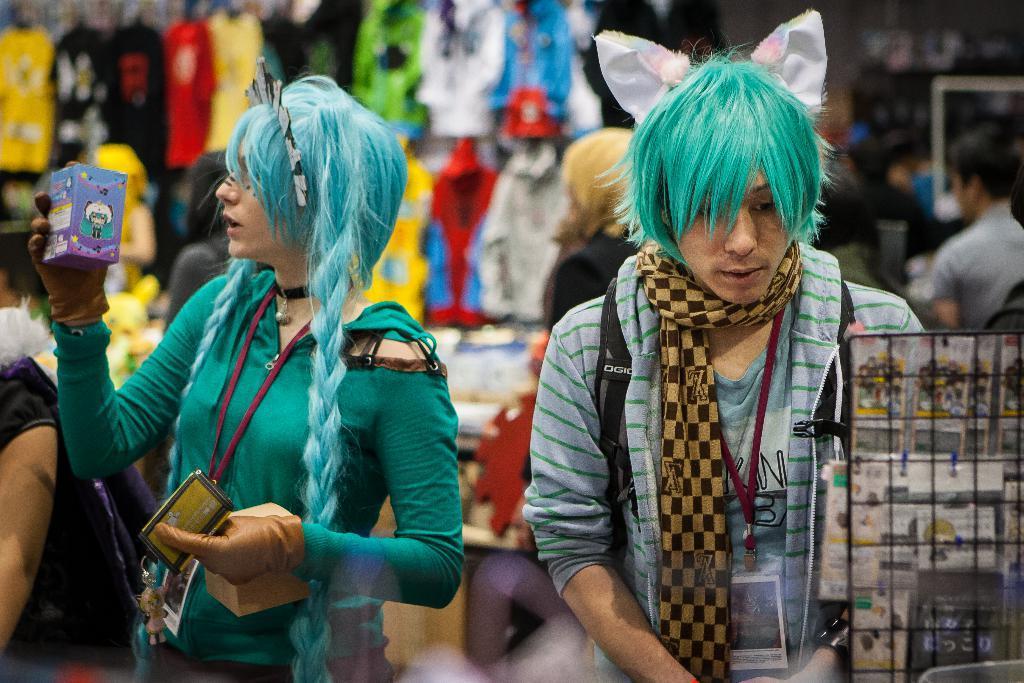Can you describe this image briefly? In this picture we can see some people and their are holding some boxes. 